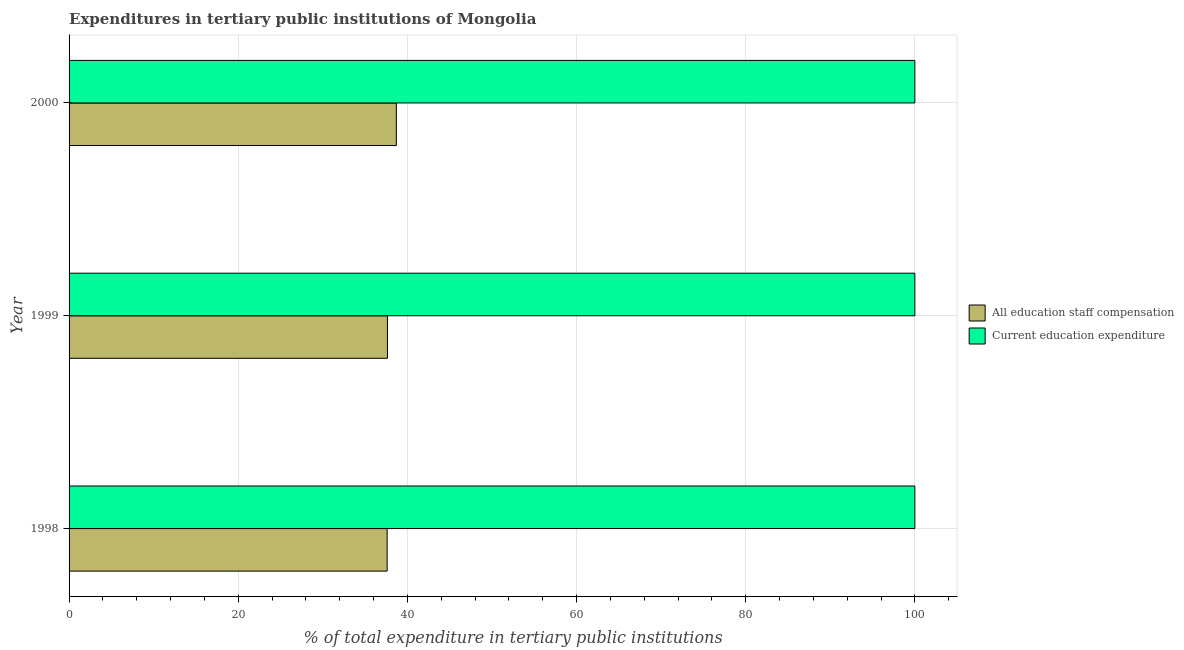Are the number of bars per tick equal to the number of legend labels?
Make the answer very short. Yes. How many bars are there on the 1st tick from the bottom?
Your response must be concise. 2. What is the label of the 3rd group of bars from the top?
Provide a short and direct response. 1998. In how many cases, is the number of bars for a given year not equal to the number of legend labels?
Your answer should be very brief. 0. What is the expenditure in education in 1998?
Make the answer very short. 100. Across all years, what is the maximum expenditure in education?
Give a very brief answer. 100. Across all years, what is the minimum expenditure in education?
Keep it short and to the point. 100. In which year was the expenditure in staff compensation minimum?
Your answer should be compact. 1998. What is the total expenditure in education in the graph?
Your answer should be compact. 300. What is the difference between the expenditure in staff compensation in 1998 and the expenditure in education in 2000?
Make the answer very short. -62.39. What is the average expenditure in education per year?
Your answer should be very brief. 100. In the year 1998, what is the difference between the expenditure in education and expenditure in staff compensation?
Your answer should be very brief. 62.39. What is the ratio of the expenditure in education in 1998 to that in 1999?
Your response must be concise. 1. What is the difference between the highest and the second highest expenditure in staff compensation?
Ensure brevity in your answer.  1.05. What is the difference between the highest and the lowest expenditure in staff compensation?
Your answer should be compact. 1.09. Is the sum of the expenditure in staff compensation in 1999 and 2000 greater than the maximum expenditure in education across all years?
Offer a terse response. No. What does the 2nd bar from the top in 1998 represents?
Keep it short and to the point. All education staff compensation. What does the 1st bar from the bottom in 1999 represents?
Your answer should be compact. All education staff compensation. Are all the bars in the graph horizontal?
Keep it short and to the point. Yes. Are the values on the major ticks of X-axis written in scientific E-notation?
Your answer should be very brief. No. How many legend labels are there?
Ensure brevity in your answer.  2. What is the title of the graph?
Your answer should be compact. Expenditures in tertiary public institutions of Mongolia. What is the label or title of the X-axis?
Make the answer very short. % of total expenditure in tertiary public institutions. What is the label or title of the Y-axis?
Keep it short and to the point. Year. What is the % of total expenditure in tertiary public institutions of All education staff compensation in 1998?
Your answer should be very brief. 37.61. What is the % of total expenditure in tertiary public institutions in All education staff compensation in 1999?
Provide a succinct answer. 37.64. What is the % of total expenditure in tertiary public institutions of Current education expenditure in 1999?
Your response must be concise. 100. What is the % of total expenditure in tertiary public institutions in All education staff compensation in 2000?
Provide a short and direct response. 38.7. What is the % of total expenditure in tertiary public institutions of Current education expenditure in 2000?
Offer a terse response. 100. Across all years, what is the maximum % of total expenditure in tertiary public institutions of All education staff compensation?
Your response must be concise. 38.7. Across all years, what is the minimum % of total expenditure in tertiary public institutions of All education staff compensation?
Your answer should be very brief. 37.61. Across all years, what is the minimum % of total expenditure in tertiary public institutions of Current education expenditure?
Your answer should be compact. 100. What is the total % of total expenditure in tertiary public institutions in All education staff compensation in the graph?
Offer a very short reply. 113.94. What is the total % of total expenditure in tertiary public institutions in Current education expenditure in the graph?
Provide a short and direct response. 300. What is the difference between the % of total expenditure in tertiary public institutions in All education staff compensation in 1998 and that in 1999?
Give a very brief answer. -0.04. What is the difference between the % of total expenditure in tertiary public institutions in Current education expenditure in 1998 and that in 1999?
Ensure brevity in your answer.  0. What is the difference between the % of total expenditure in tertiary public institutions in All education staff compensation in 1998 and that in 2000?
Your response must be concise. -1.09. What is the difference between the % of total expenditure in tertiary public institutions of All education staff compensation in 1999 and that in 2000?
Your response must be concise. -1.05. What is the difference between the % of total expenditure in tertiary public institutions in Current education expenditure in 1999 and that in 2000?
Keep it short and to the point. 0. What is the difference between the % of total expenditure in tertiary public institutions of All education staff compensation in 1998 and the % of total expenditure in tertiary public institutions of Current education expenditure in 1999?
Make the answer very short. -62.39. What is the difference between the % of total expenditure in tertiary public institutions in All education staff compensation in 1998 and the % of total expenditure in tertiary public institutions in Current education expenditure in 2000?
Give a very brief answer. -62.39. What is the difference between the % of total expenditure in tertiary public institutions of All education staff compensation in 1999 and the % of total expenditure in tertiary public institutions of Current education expenditure in 2000?
Give a very brief answer. -62.36. What is the average % of total expenditure in tertiary public institutions of All education staff compensation per year?
Provide a short and direct response. 37.98. In the year 1998, what is the difference between the % of total expenditure in tertiary public institutions of All education staff compensation and % of total expenditure in tertiary public institutions of Current education expenditure?
Provide a short and direct response. -62.39. In the year 1999, what is the difference between the % of total expenditure in tertiary public institutions in All education staff compensation and % of total expenditure in tertiary public institutions in Current education expenditure?
Offer a terse response. -62.36. In the year 2000, what is the difference between the % of total expenditure in tertiary public institutions of All education staff compensation and % of total expenditure in tertiary public institutions of Current education expenditure?
Your response must be concise. -61.3. What is the ratio of the % of total expenditure in tertiary public institutions of All education staff compensation in 1998 to that in 2000?
Provide a short and direct response. 0.97. What is the ratio of the % of total expenditure in tertiary public institutions of Current education expenditure in 1998 to that in 2000?
Make the answer very short. 1. What is the ratio of the % of total expenditure in tertiary public institutions in All education staff compensation in 1999 to that in 2000?
Provide a short and direct response. 0.97. What is the difference between the highest and the second highest % of total expenditure in tertiary public institutions in All education staff compensation?
Give a very brief answer. 1.05. What is the difference between the highest and the lowest % of total expenditure in tertiary public institutions in All education staff compensation?
Offer a very short reply. 1.09. What is the difference between the highest and the lowest % of total expenditure in tertiary public institutions in Current education expenditure?
Offer a very short reply. 0. 